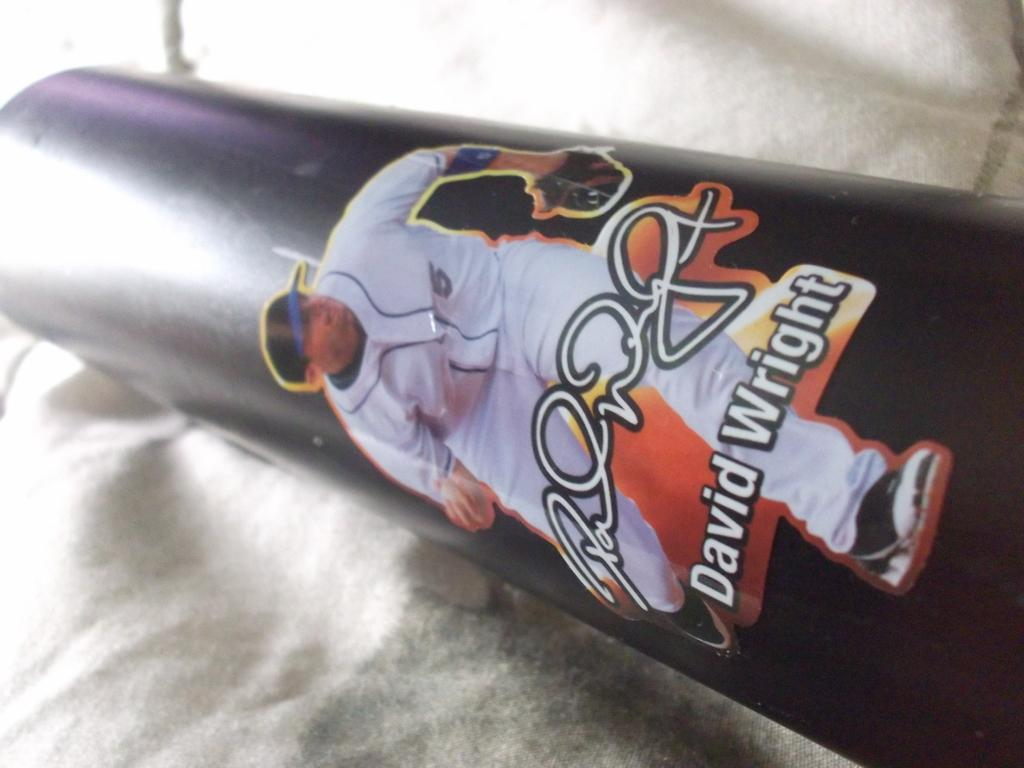What is depicted on the sticker in the image? There is a sticker of a man on a pipe in the image. What can be seen at the bottom of the image? There is a cloth at the bottom of the image. What type of guide is present in the image? There is no guide present in the image; it only features a sticker of a man on a pipe and a cloth at the bottom. How does the nut contribute to the development in the image? There is no nut or development mentioned in the image; it only contains a sticker and a cloth. 